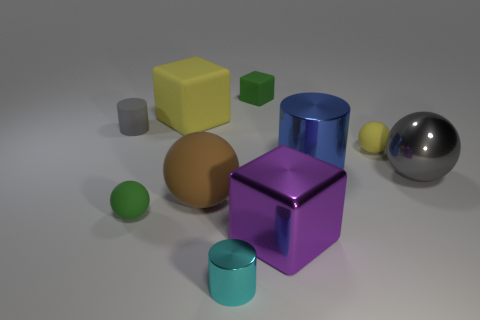Is the number of brown rubber spheres greater than the number of tiny blue balls?
Provide a succinct answer. Yes. Are the brown ball and the small gray cylinder made of the same material?
Make the answer very short. Yes. How many metallic objects are either large cyan things or cyan things?
Keep it short and to the point. 1. There is a block that is the same size as the purple thing; what color is it?
Your response must be concise. Yellow. How many other gray matte things have the same shape as the small gray thing?
Provide a succinct answer. 0. How many cylinders are either tiny yellow matte objects or gray metallic objects?
Offer a very short reply. 0. There is a small green matte object behind the blue object; is it the same shape as the large object that is to the right of the big cylinder?
Your answer should be compact. No. What is the big yellow object made of?
Your answer should be very brief. Rubber. The small matte object that is the same color as the big matte block is what shape?
Ensure brevity in your answer.  Sphere. What number of other metal things have the same size as the brown thing?
Give a very brief answer. 3. 